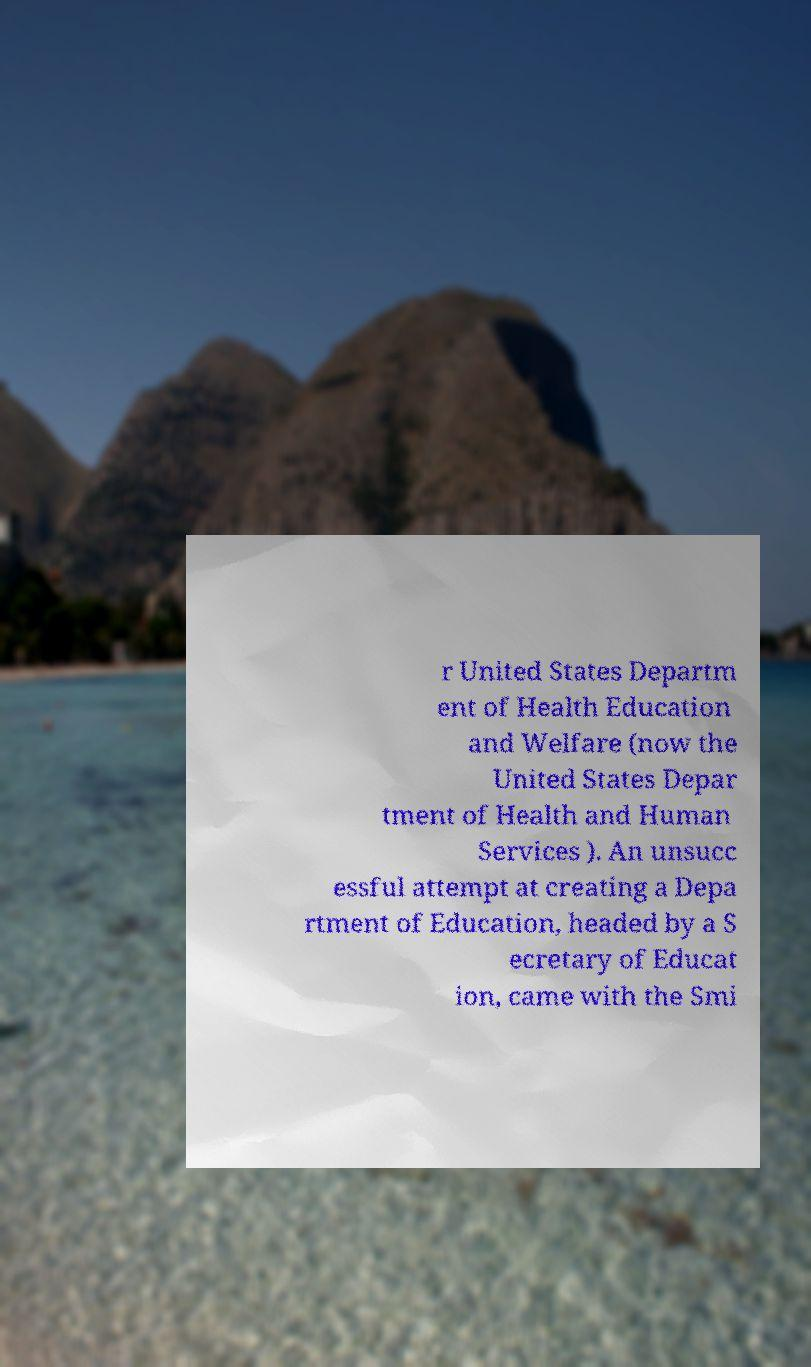Could you assist in decoding the text presented in this image and type it out clearly? r United States Departm ent of Health Education and Welfare (now the United States Depar tment of Health and Human Services ). An unsucc essful attempt at creating a Depa rtment of Education, headed by a S ecretary of Educat ion, came with the Smi 